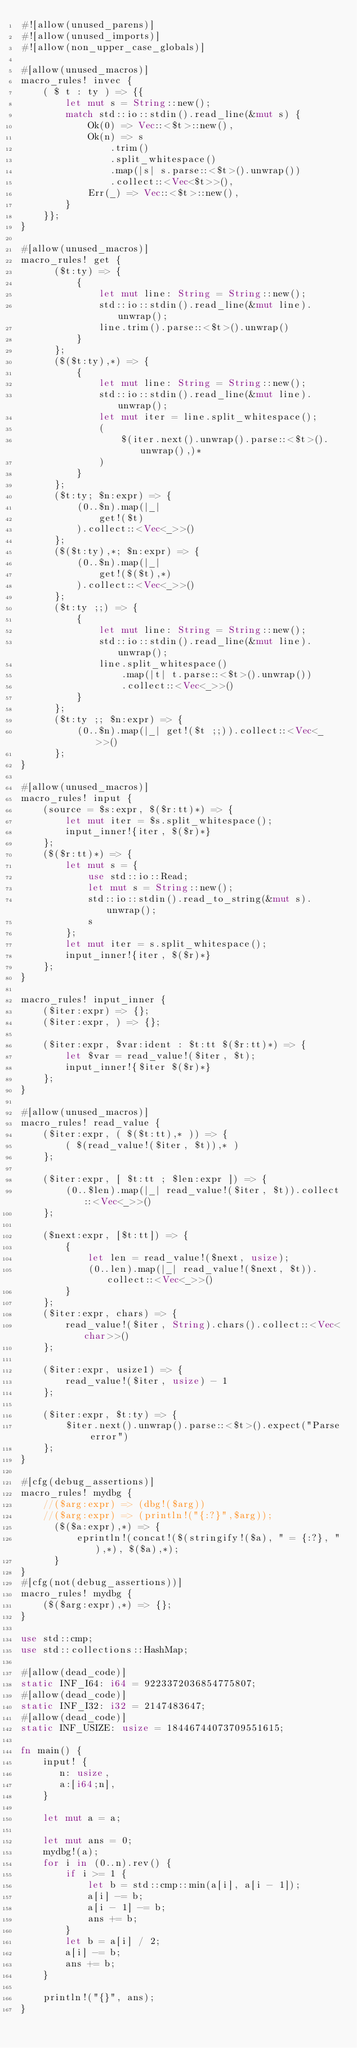Convert code to text. <code><loc_0><loc_0><loc_500><loc_500><_Rust_>#![allow(unused_parens)]
#![allow(unused_imports)]
#![allow(non_upper_case_globals)]

#[allow(unused_macros)]
macro_rules! invec {
    ( $ t : ty ) => {{
        let mut s = String::new();
        match std::io::stdin().read_line(&mut s) {
            Ok(0) => Vec::<$t>::new(),
            Ok(n) => s
                .trim()
                .split_whitespace()
                .map(|s| s.parse::<$t>().unwrap())
                .collect::<Vec<$t>>(),
            Err(_) => Vec::<$t>::new(),
        }
    }};
}

#[allow(unused_macros)]
macro_rules! get {
      ($t:ty) => {
          {
              let mut line: String = String::new();
              std::io::stdin().read_line(&mut line).unwrap();
              line.trim().parse::<$t>().unwrap()
          }
      };
      ($($t:ty),*) => {
          {
              let mut line: String = String::new();
              std::io::stdin().read_line(&mut line).unwrap();
              let mut iter = line.split_whitespace();
              (
                  $(iter.next().unwrap().parse::<$t>().unwrap(),)*
              )
          }
      };
      ($t:ty; $n:expr) => {
          (0..$n).map(|_|
              get!($t)
          ).collect::<Vec<_>>()
      };
      ($($t:ty),*; $n:expr) => {
          (0..$n).map(|_|
              get!($($t),*)
          ).collect::<Vec<_>>()
      };
      ($t:ty ;;) => {
          {
              let mut line: String = String::new();
              std::io::stdin().read_line(&mut line).unwrap();
              line.split_whitespace()
                  .map(|t| t.parse::<$t>().unwrap())
                  .collect::<Vec<_>>()
          }
      };
      ($t:ty ;; $n:expr) => {
          (0..$n).map(|_| get!($t ;;)).collect::<Vec<_>>()
      };
}

#[allow(unused_macros)]
macro_rules! input {
    (source = $s:expr, $($r:tt)*) => {
        let mut iter = $s.split_whitespace();
        input_inner!{iter, $($r)*}
    };
    ($($r:tt)*) => {
        let mut s = {
            use std::io::Read;
            let mut s = String::new();
            std::io::stdin().read_to_string(&mut s).unwrap();
            s
        };
        let mut iter = s.split_whitespace();
        input_inner!{iter, $($r)*}
    };
}

macro_rules! input_inner {
    ($iter:expr) => {};
    ($iter:expr, ) => {};

    ($iter:expr, $var:ident : $t:tt $($r:tt)*) => {
        let $var = read_value!($iter, $t);
        input_inner!{$iter $($r)*}
    };
}

#[allow(unused_macros)]
macro_rules! read_value {
    ($iter:expr, ( $($t:tt),* )) => {
        ( $(read_value!($iter, $t)),* )
    };

    ($iter:expr, [ $t:tt ; $len:expr ]) => {
        (0..$len).map(|_| read_value!($iter, $t)).collect::<Vec<_>>()
    };

    ($next:expr, [$t:tt]) => {
        {
            let len = read_value!($next, usize);
            (0..len).map(|_| read_value!($next, $t)).collect::<Vec<_>>()
        }
    };
    ($iter:expr, chars) => {
        read_value!($iter, String).chars().collect::<Vec<char>>()
    };

    ($iter:expr, usize1) => {
        read_value!($iter, usize) - 1
    };

    ($iter:expr, $t:ty) => {
        $iter.next().unwrap().parse::<$t>().expect("Parse error")
    };
}

#[cfg(debug_assertions)]
macro_rules! mydbg {
    //($arg:expr) => (dbg!($arg))
    //($arg:expr) => (println!("{:?}",$arg));
      ($($a:expr),*) => {
          eprintln!(concat!($(stringify!($a), " = {:?}, "),*), $($a),*);
      }
}
#[cfg(not(debug_assertions))]
macro_rules! mydbg {
    ($($arg:expr),*) => {};
}

use std::cmp;
use std::collections::HashMap;

#[allow(dead_code)]
static INF_I64: i64 = 9223372036854775807;
#[allow(dead_code)]
static INF_I32: i32 = 2147483647;
#[allow(dead_code)]
static INF_USIZE: usize = 18446744073709551615;

fn main() {
    input! {
       n: usize,
       a:[i64;n],
    }

    let mut a = a;

    let mut ans = 0;
    mydbg!(a);
    for i in (0..n).rev() {
        if i >= 1 {
            let b = std::cmp::min(a[i], a[i - 1]);
            a[i] -= b;
            a[i - 1] -= b;
            ans += b;
        }
        let b = a[i] / 2;
        a[i] -= b;
        ans += b;
    }

    println!("{}", ans);
}
</code> 